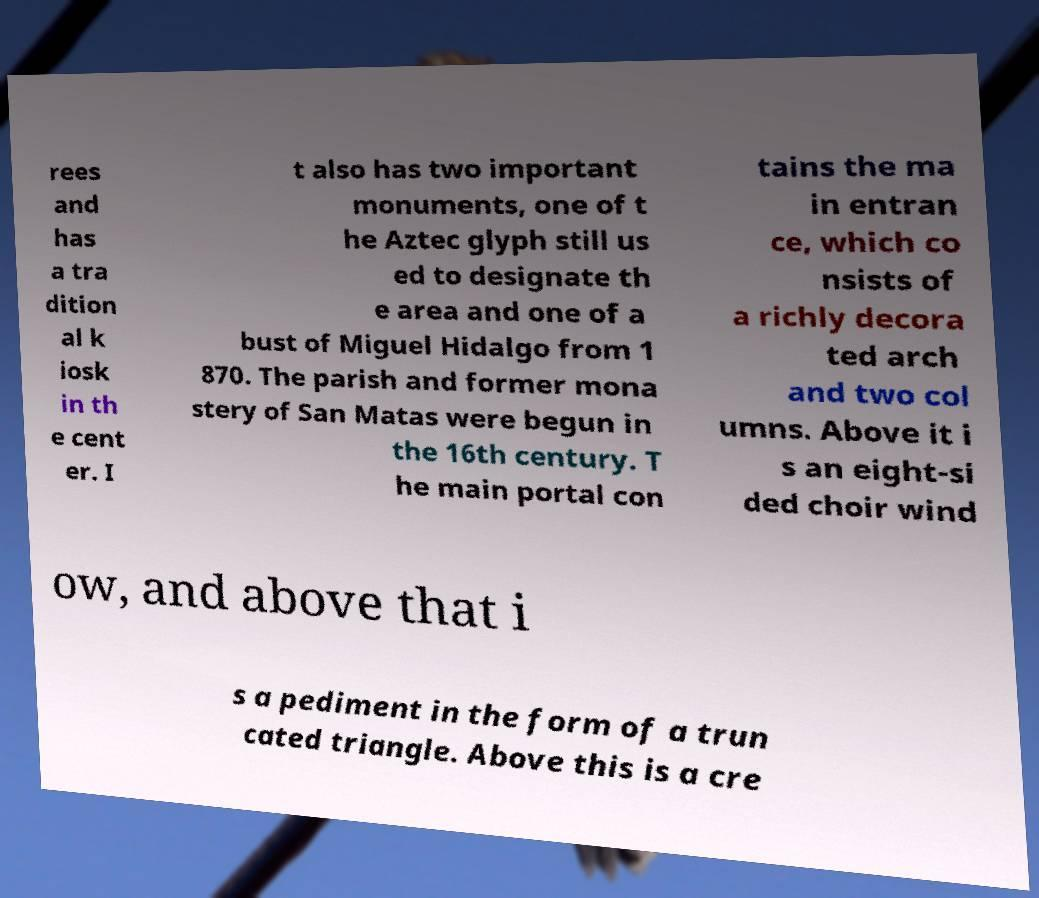Please identify and transcribe the text found in this image. rees and has a tra dition al k iosk in th e cent er. I t also has two important monuments, one of t he Aztec glyph still us ed to designate th e area and one of a bust of Miguel Hidalgo from 1 870. The parish and former mona stery of San Matas were begun in the 16th century. T he main portal con tains the ma in entran ce, which co nsists of a richly decora ted arch and two col umns. Above it i s an eight-si ded choir wind ow, and above that i s a pediment in the form of a trun cated triangle. Above this is a cre 